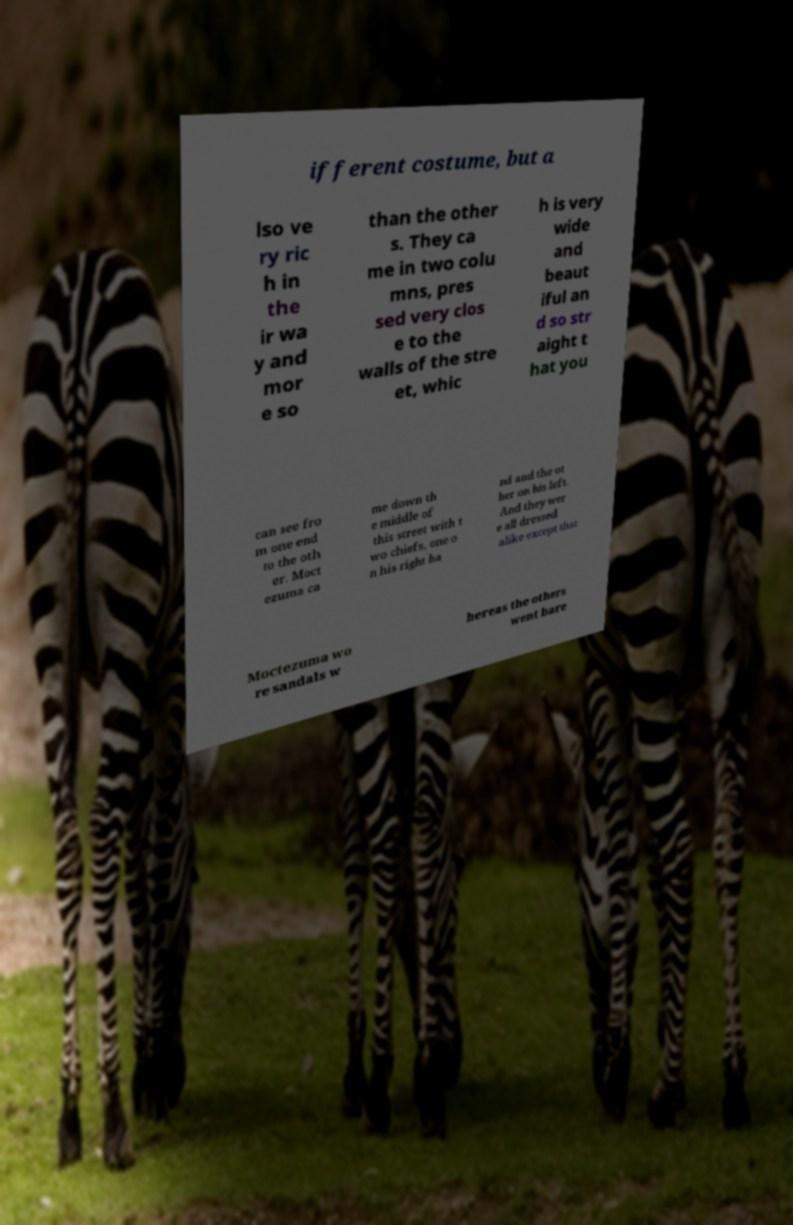Please read and relay the text visible in this image. What does it say? ifferent costume, but a lso ve ry ric h in the ir wa y and mor e so than the other s. They ca me in two colu mns, pres sed very clos e to the walls of the stre et, whic h is very wide and beaut iful an d so str aight t hat you can see fro m one end to the oth er. Moct ezuma ca me down th e middle of this street with t wo chiefs, one o n his right ha nd and the ot her on his left. And they wer e all dressed alike except that Moctezuma wo re sandals w hereas the others went bare 